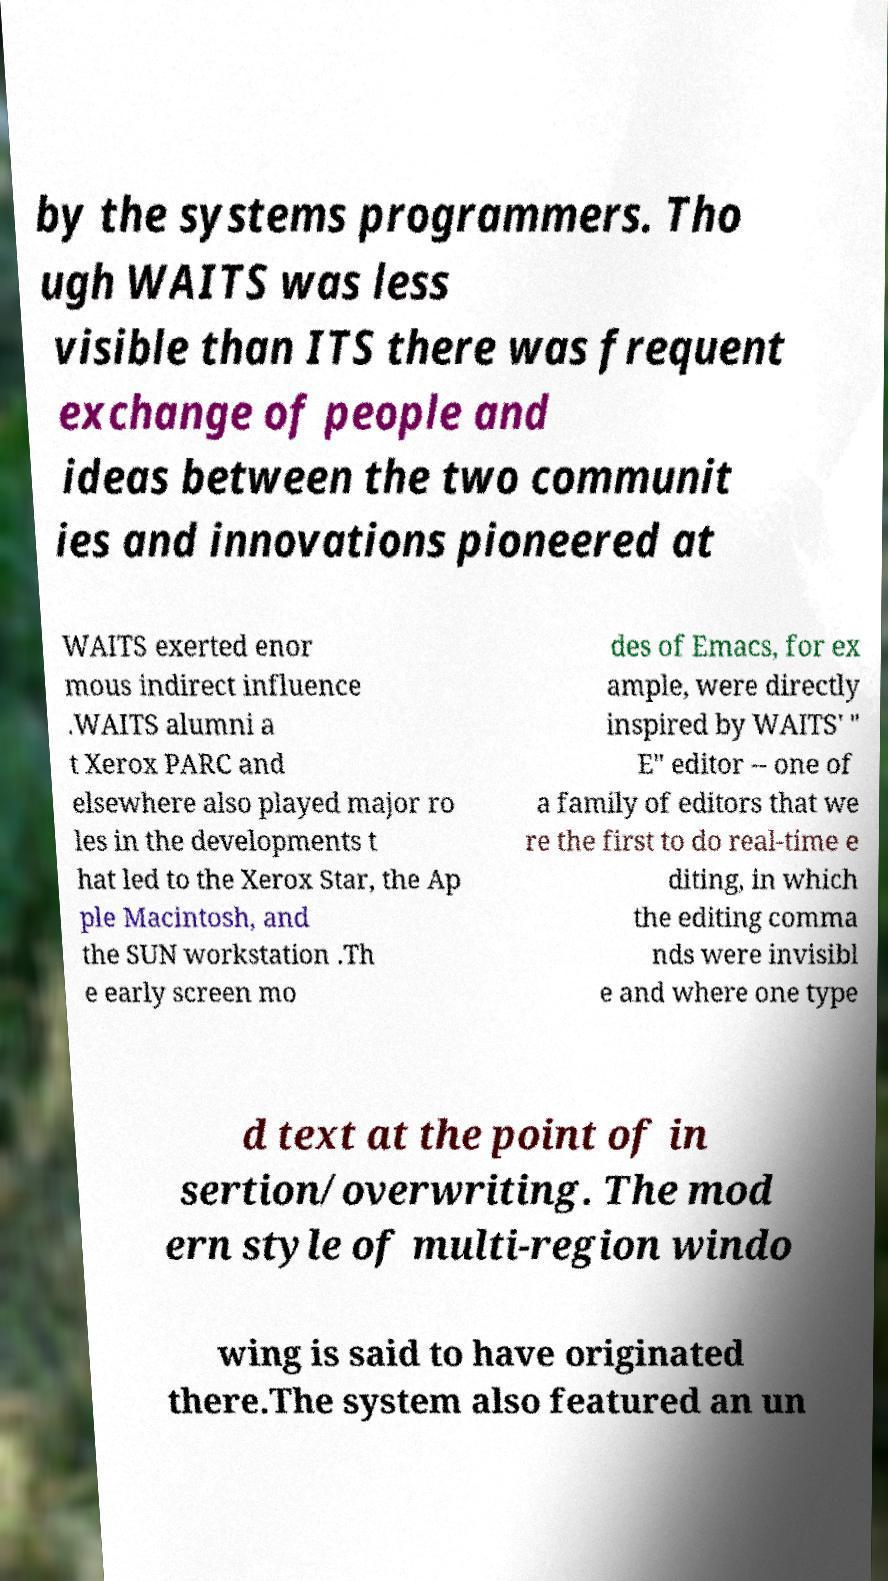Could you extract and type out the text from this image? by the systems programmers. Tho ugh WAITS was less visible than ITS there was frequent exchange of people and ideas between the two communit ies and innovations pioneered at WAITS exerted enor mous indirect influence .WAITS alumni a t Xerox PARC and elsewhere also played major ro les in the developments t hat led to the Xerox Star, the Ap ple Macintosh, and the SUN workstation .Th e early screen mo des of Emacs, for ex ample, were directly inspired by WAITS' " E" editor -- one of a family of editors that we re the first to do real-time e diting, in which the editing comma nds were invisibl e and where one type d text at the point of in sertion/overwriting. The mod ern style of multi-region windo wing is said to have originated there.The system also featured an un 